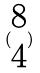<formula> <loc_0><loc_0><loc_500><loc_500>( \begin{matrix} 8 \\ 4 \end{matrix} )</formula> 